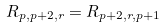<formula> <loc_0><loc_0><loc_500><loc_500>R _ { p , p + 2 , r } = R _ { p + 2 , r , p + 1 }</formula> 